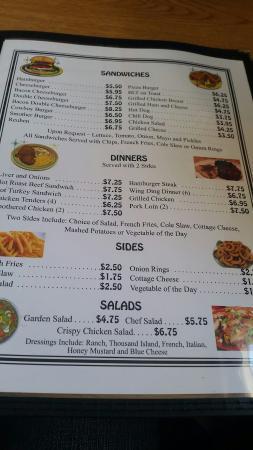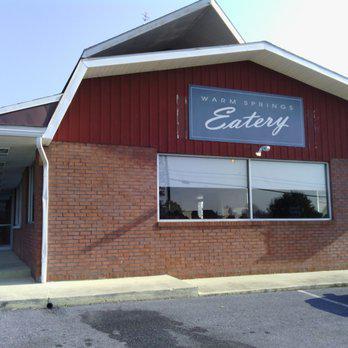The first image is the image on the left, the second image is the image on the right. For the images shown, is this caption "The right image shows a diner exterior with a rectangular sign over glass windows in front of a parking lot." true? Answer yes or no. Yes. The first image is the image on the left, the second image is the image on the right. Examine the images to the left and right. Is the description "Both images contain menus." accurate? Answer yes or no. No. 